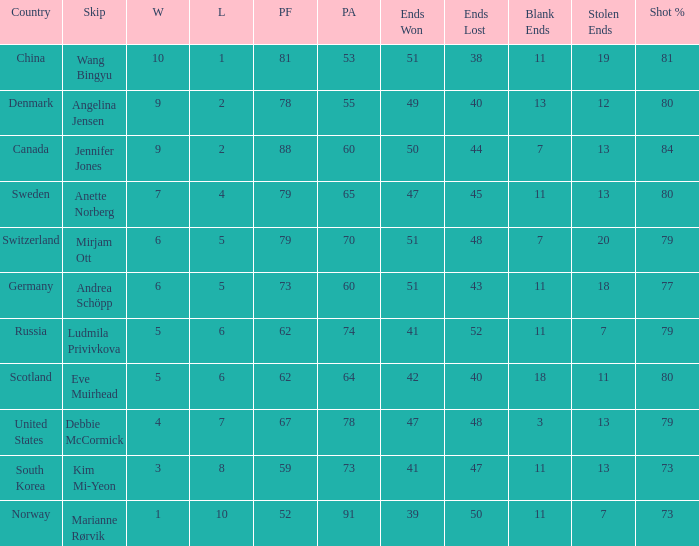Andrea Schöpp is the skip of which country? Germany. 